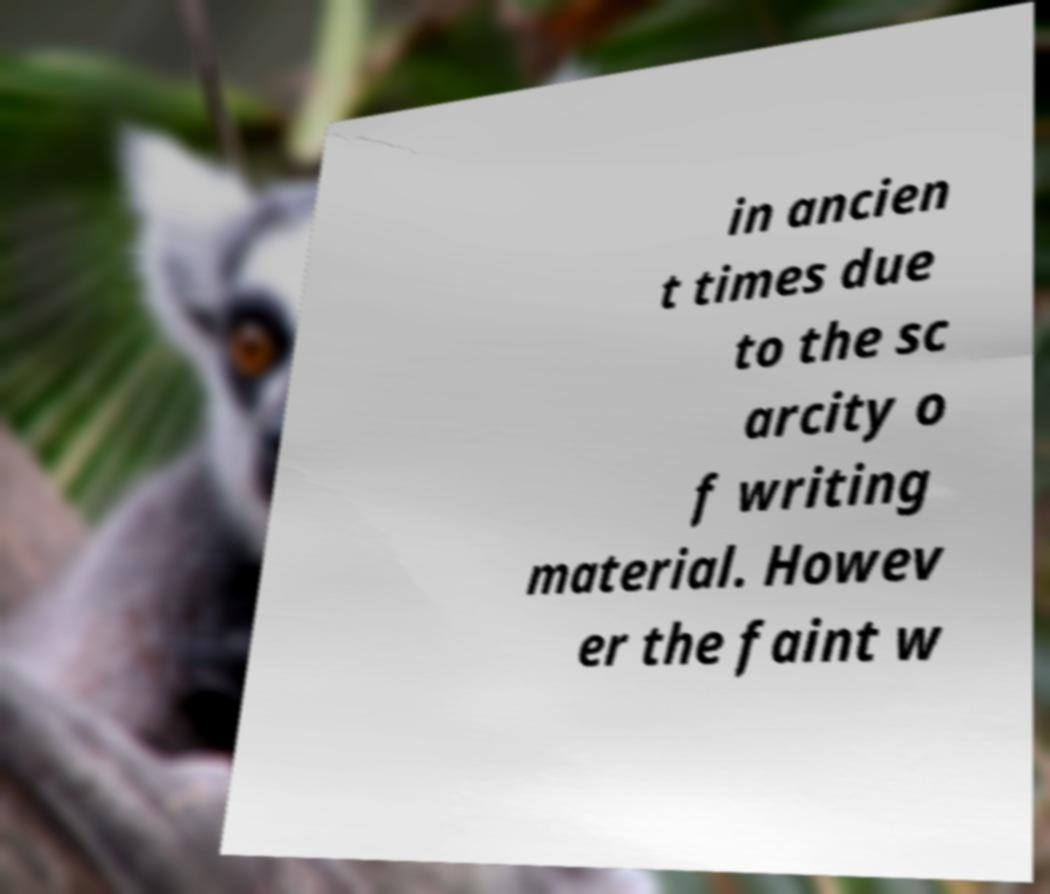Can you accurately transcribe the text from the provided image for me? in ancien t times due to the sc arcity o f writing material. Howev er the faint w 